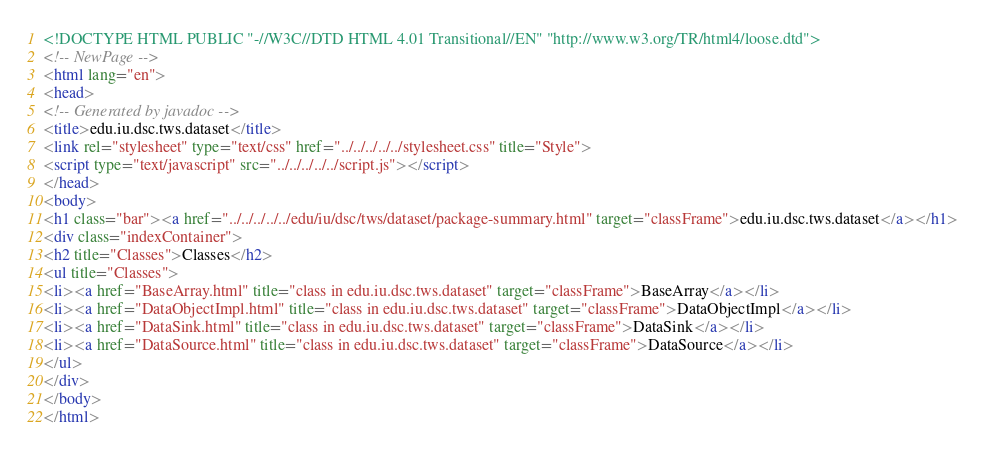<code> <loc_0><loc_0><loc_500><loc_500><_HTML_><!DOCTYPE HTML PUBLIC "-//W3C//DTD HTML 4.01 Transitional//EN" "http://www.w3.org/TR/html4/loose.dtd">
<!-- NewPage -->
<html lang="en">
<head>
<!-- Generated by javadoc -->
<title>edu.iu.dsc.tws.dataset</title>
<link rel="stylesheet" type="text/css" href="../../../../../stylesheet.css" title="Style">
<script type="text/javascript" src="../../../../../script.js"></script>
</head>
<body>
<h1 class="bar"><a href="../../../../../edu/iu/dsc/tws/dataset/package-summary.html" target="classFrame">edu.iu.dsc.tws.dataset</a></h1>
<div class="indexContainer">
<h2 title="Classes">Classes</h2>
<ul title="Classes">
<li><a href="BaseArray.html" title="class in edu.iu.dsc.tws.dataset" target="classFrame">BaseArray</a></li>
<li><a href="DataObjectImpl.html" title="class in edu.iu.dsc.tws.dataset" target="classFrame">DataObjectImpl</a></li>
<li><a href="DataSink.html" title="class in edu.iu.dsc.tws.dataset" target="classFrame">DataSink</a></li>
<li><a href="DataSource.html" title="class in edu.iu.dsc.tws.dataset" target="classFrame">DataSource</a></li>
</ul>
</div>
</body>
</html>
</code> 